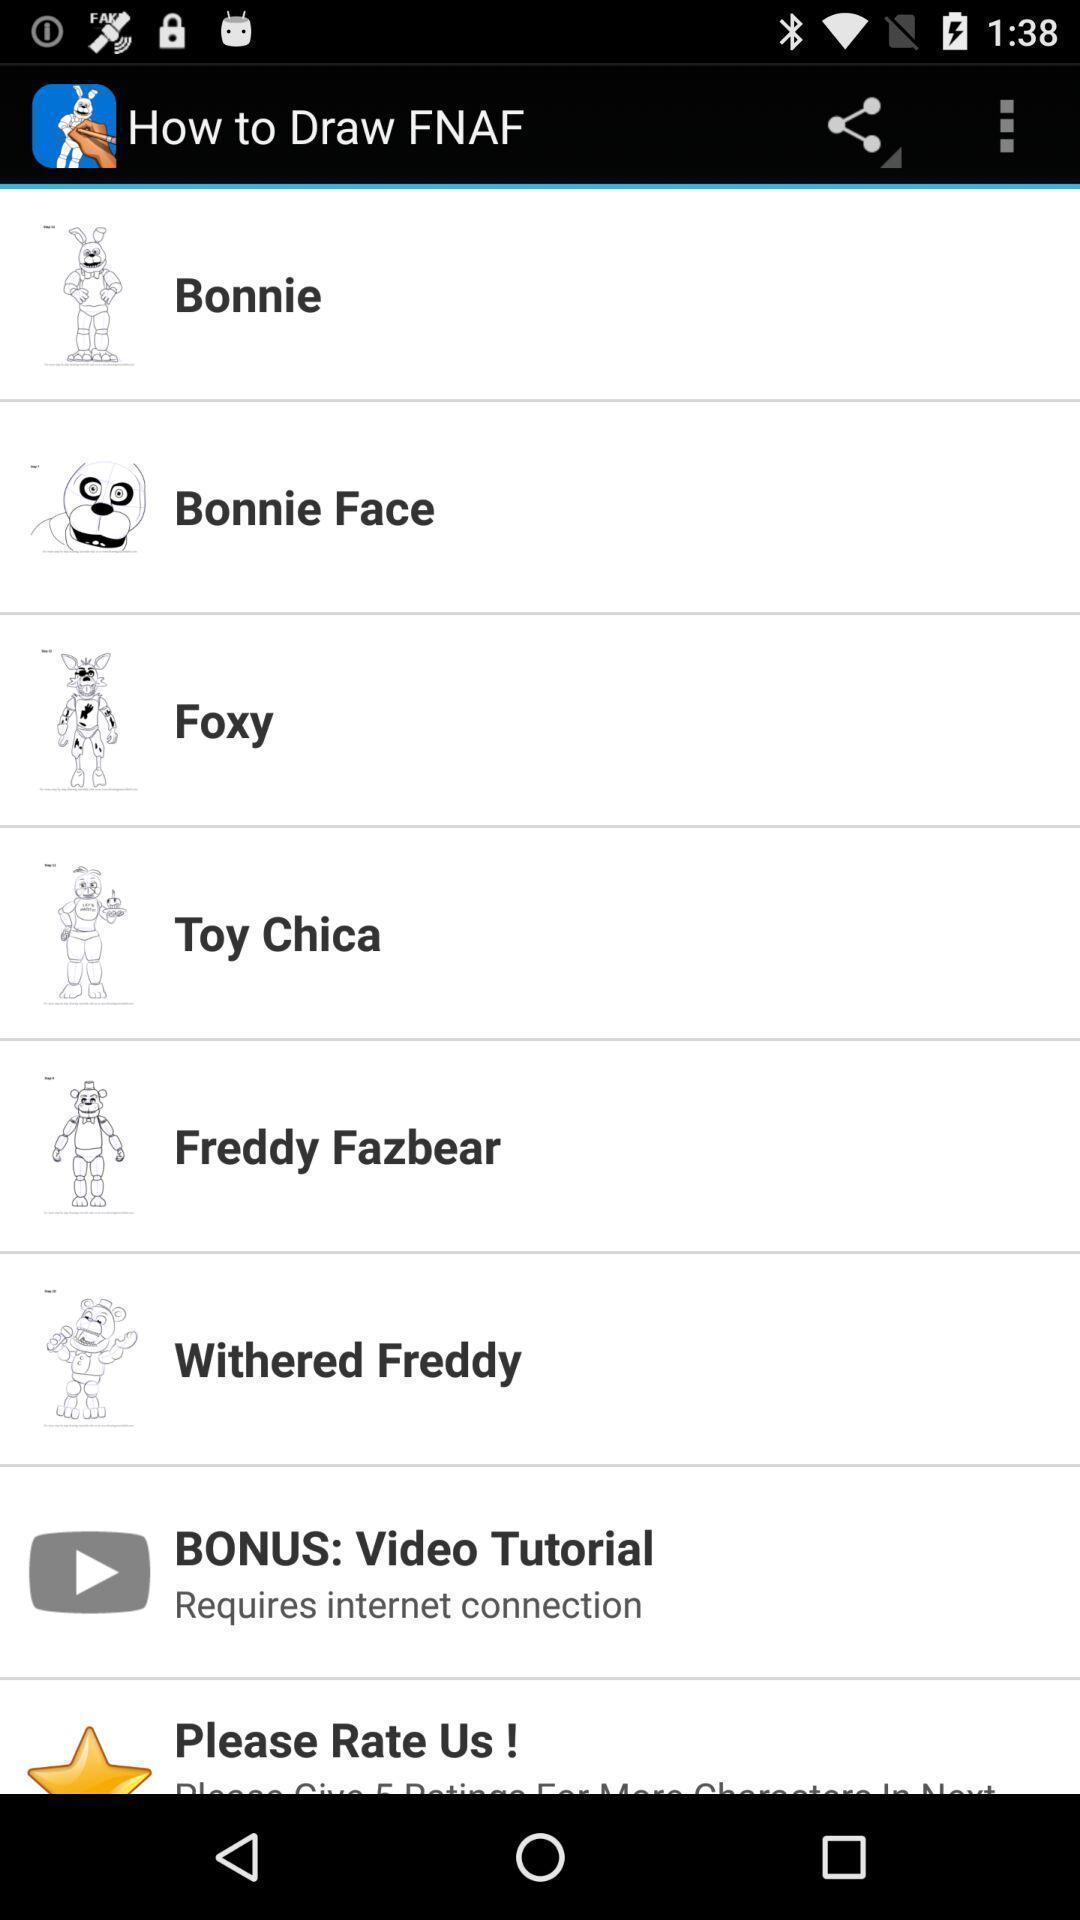Tell me what you see in this picture. Page with different drawings in a drawing app. 